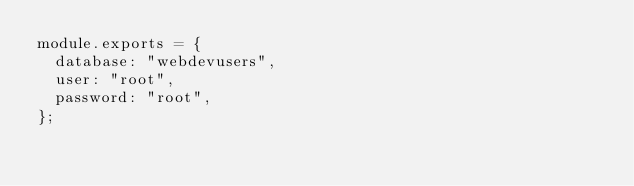Convert code to text. <code><loc_0><loc_0><loc_500><loc_500><_JavaScript_>module.exports = {
  database: "webdevusers",
  user: "root",
  password: "root",
};
</code> 